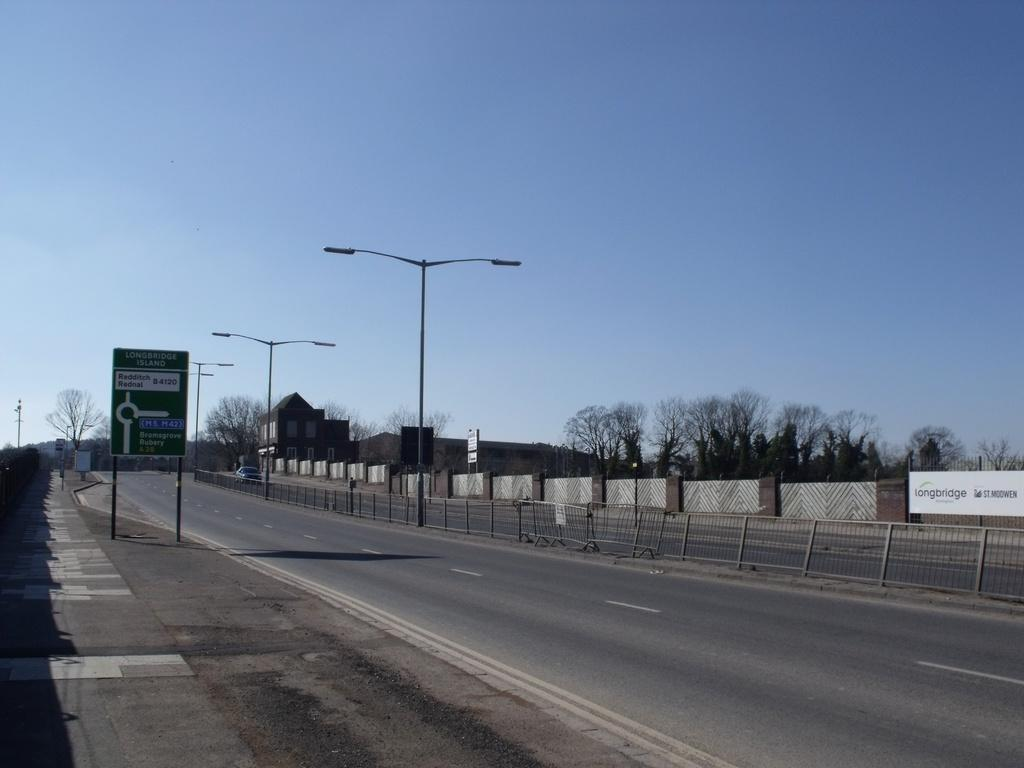What color is the sky in the image? The sky is blue in the image. What can be seen on the road in the image? There is a vehicle on the road in the image. What type of barrier is present in the image? There is a fence in the image. What type of entrance is visible in the image? There is a gate in the image. What type of signage is present in the image? There are boards and hoardings in the image. What type of vertical structures are present in the image? There are light poles in the image. What type of vegetation is present in the image? There are trees in the image. What type of building is present in the image? There is a house in the image. What feature of the house can be seen in the image? The house has windows. Can you see any mountains in the image? There are no mountains present in the image. How many turkeys are visible in the image? There are no turkeys present in the image. What type of furniture is visible in the image? There is no furniture visible in the image. 